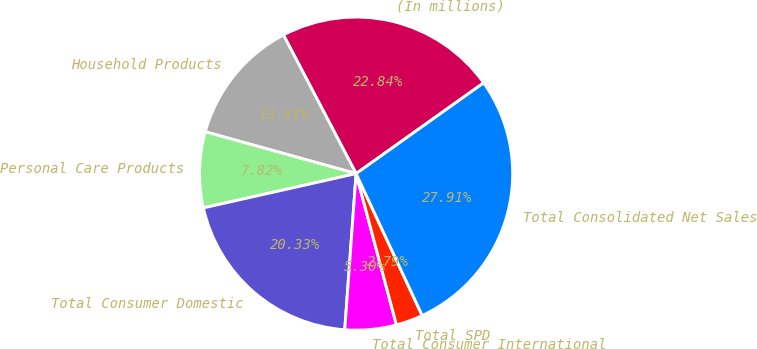Convert chart to OTSL. <chart><loc_0><loc_0><loc_500><loc_500><pie_chart><fcel>(In millions)<fcel>Household Products<fcel>Personal Care Products<fcel>Total Consumer Domestic<fcel>Total Consumer International<fcel>Total SPD<fcel>Total Consolidated Net Sales<nl><fcel>22.84%<fcel>13.01%<fcel>7.82%<fcel>20.33%<fcel>5.3%<fcel>2.79%<fcel>27.91%<nl></chart> 